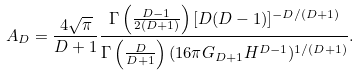Convert formula to latex. <formula><loc_0><loc_0><loc_500><loc_500>A _ { D } = \frac { 4 \sqrt { \pi } } { D + 1 } \frac { \Gamma \left ( \frac { D - 1 } { 2 ( D + 1 ) } \right ) [ D ( D - 1 ) ] ^ { - D / ( D + 1 ) } } { \Gamma \left ( \frac { D } { D + 1 } \right ) ( 1 6 \pi G _ { D + 1 } H ^ { D - 1 } ) ^ { 1 / ( D + 1 ) } } .</formula> 